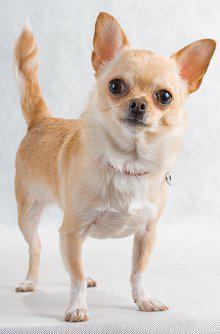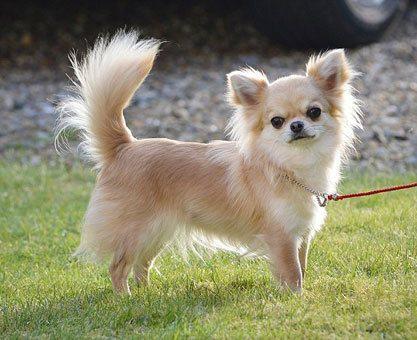The first image is the image on the left, the second image is the image on the right. Given the left and right images, does the statement "There are two chihuahuas with their heads to the right and tails up to the left." hold true? Answer yes or no. Yes. 